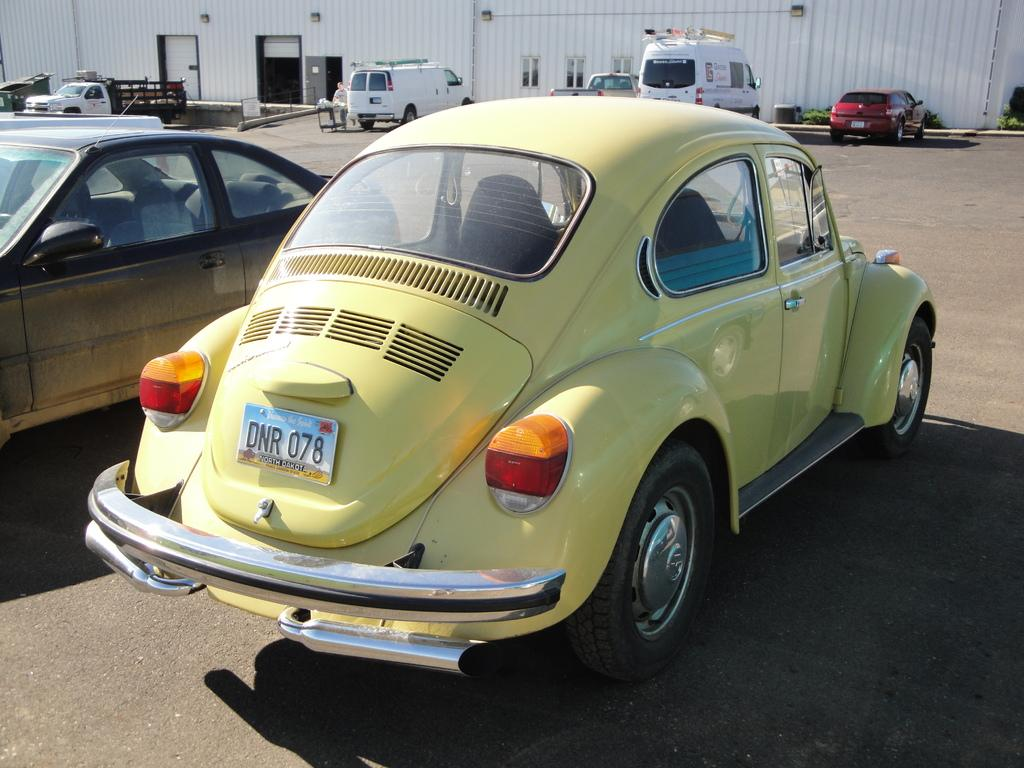What types of vehicles are on the ground in the image? The specific types of vehicles are not mentioned, but there are vehicles on the ground in the image. What can be seen in the background of the image? There is a shed and plants visible in the background of the image. What type of flesh can be seen hanging from the shed in the image? There is no flesh visible in the image, as it features vehicles on the ground and a shed with plants in the background. 